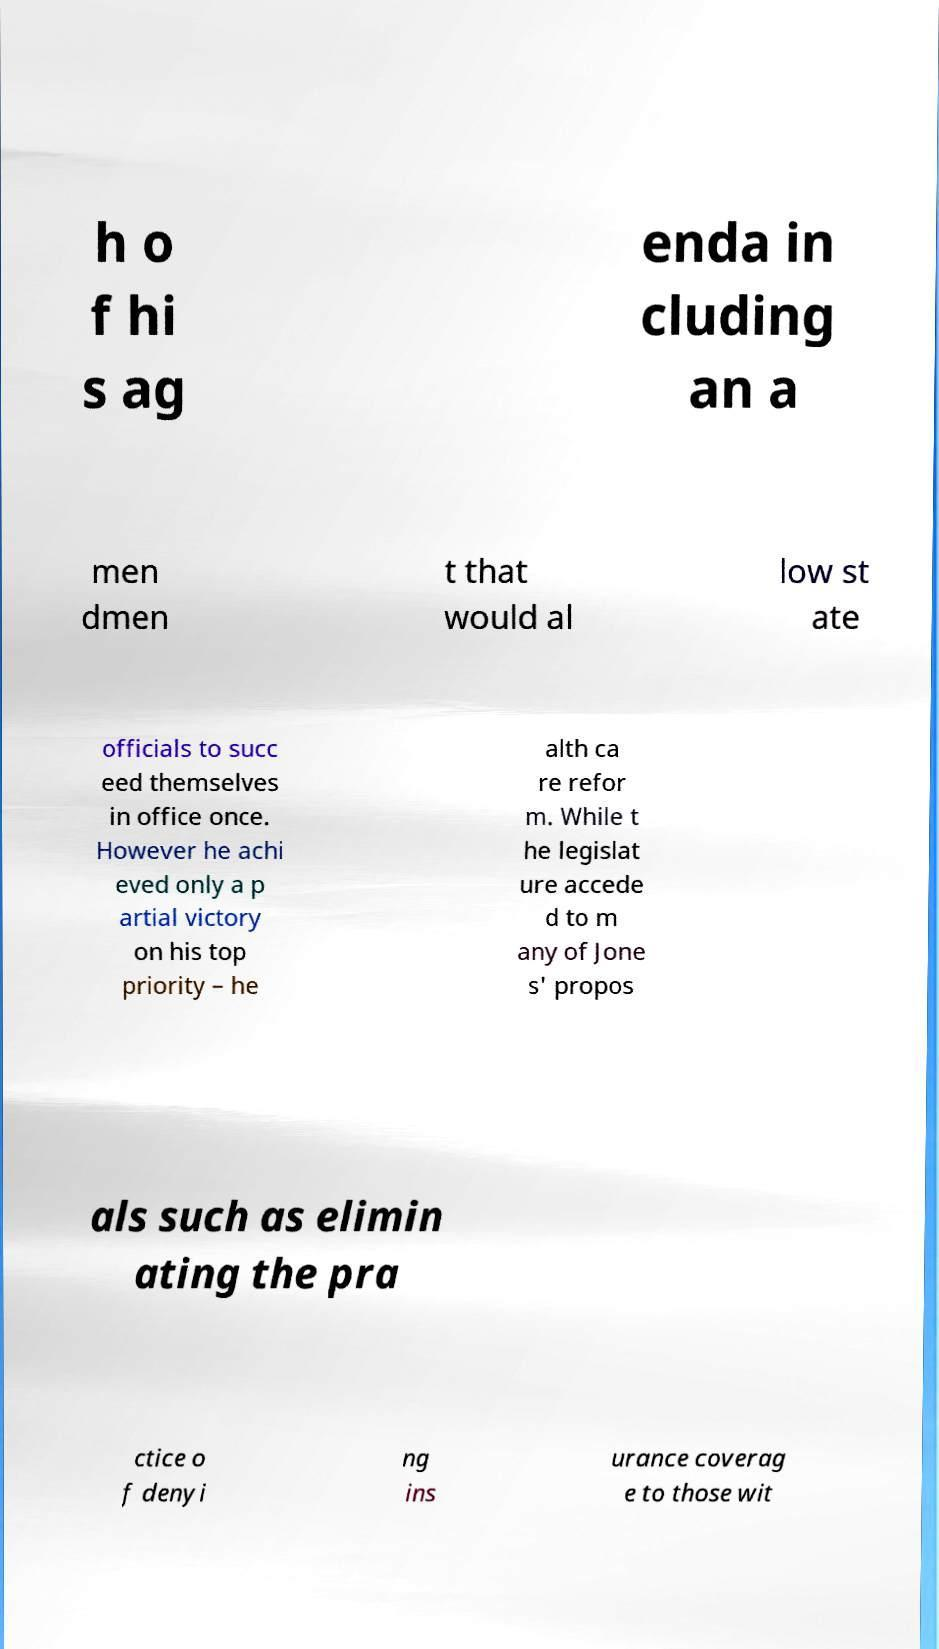I need the written content from this picture converted into text. Can you do that? h o f hi s ag enda in cluding an a men dmen t that would al low st ate officials to succ eed themselves in office once. However he achi eved only a p artial victory on his top priority – he alth ca re refor m. While t he legislat ure accede d to m any of Jone s' propos als such as elimin ating the pra ctice o f denyi ng ins urance coverag e to those wit 